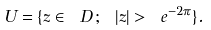<formula> <loc_0><loc_0><loc_500><loc_500>U = \{ z \in \ D \, ; \ | z | > \ e ^ { - 2 \pi } \} .</formula> 